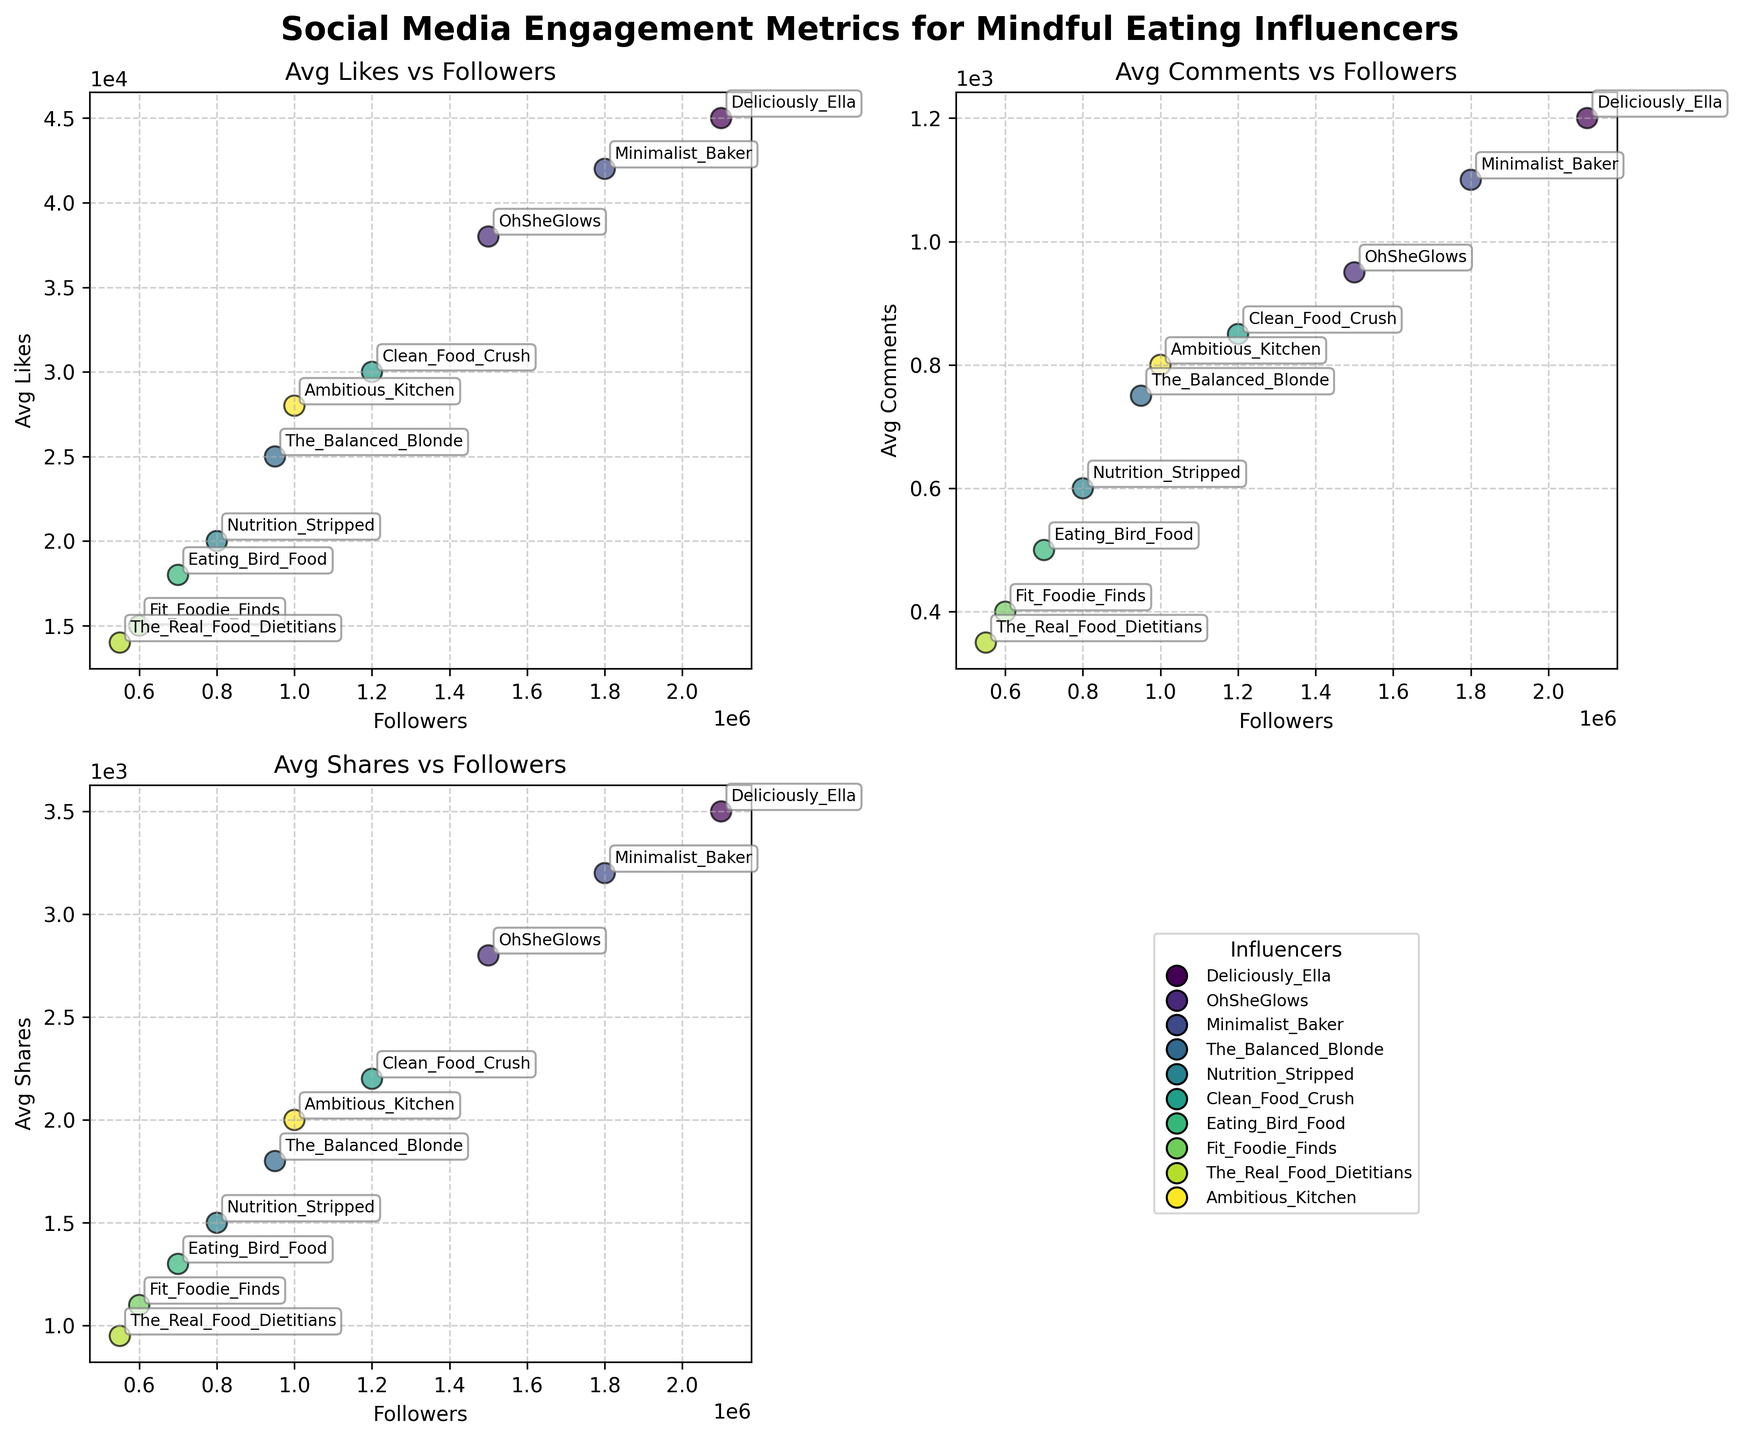What's the title of the figure? The title is located at the top center of the figure and reads "Social Media Engagement Metrics for Mindful Eating Influencers."
Answer: Social Media Engagement Metrics for Mindful Eating Influencers How many scatter plots are given in the figure? The figure consists of a 2x2 grid where three plots have scatter plots and the fourth subplot is blank.
Answer: 3 Which influencer has the highest average likes? By looking at the scatter plot of Avg Likes vs Followers, the point corresponding to the highest average likes can be identified. The label for this point is "Deliciously_Ella."
Answer: Deliciously_Ella What is the average number of comments for The Balanced Blonde? Locate the scatter plot of Avg Comments vs Followers and find the point labeled "The_Balanced_Blonde," then read off its Avg Comments value.
Answer: 750 Compare the average likes of Fit Foodie Finds and The Real Food Dietitians. Who has more? Find the points labeled "Fit_Foodie_Finds" and "The_Real_Food_Dietitians" in the Avg Likes vs Followers scatter plot and compare their values. Fit_Foodie_Finds has 15000 likes, while The_Real_Food_Dietitians has 14000 likes.
Answer: Fit_Foodie_Finds Which influencer has the closest number of average shares to Ambitious Kitchen? Identify the value of Avg Shares for "Ambitious_Kitchen" from the scatter plot and compare it with other influencers' values. Ambitious_Kitchen has 2000 shares, and The_Balanced_Blonde has 1800 shares.
Answer: The_Balanced_Blonde What's the average number of comments for the influencer with 800,000 followers? Find the point with 800,000 followers in the Avg Comments vs Followers scatter plot and identify its label as "Nutrition_Stripped," then check its Avg Comments value.
Answer: 600 Which influencer has less than 1,000 average comments but more than 1,500 average shares? Check the scatter plots of Avg Comments vs Followers and Avg Shares vs Followers to see which influencer meets both conditions. "Minimalist_Baker" has 1100 comments and 3200 shares, and "OhSheGlows" has 950 comments and 2800 shares. "OhSheGlows" fits the criteria.
Answer: OhSheGlows Are there any influencers with fewer than 1,000 average likes? Look at the scatter plot of Avg Likes vs Followers to see if any points representing the influencers are below 1,000 likes. No points are below this threshold.
Answer: No 